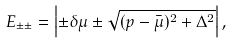<formula> <loc_0><loc_0><loc_500><loc_500>E _ { \pm \pm } = \left | \pm \delta \mu \pm \sqrt { ( p - \bar { \mu } ) ^ { 2 } + \Delta ^ { 2 } } \right | ,</formula> 